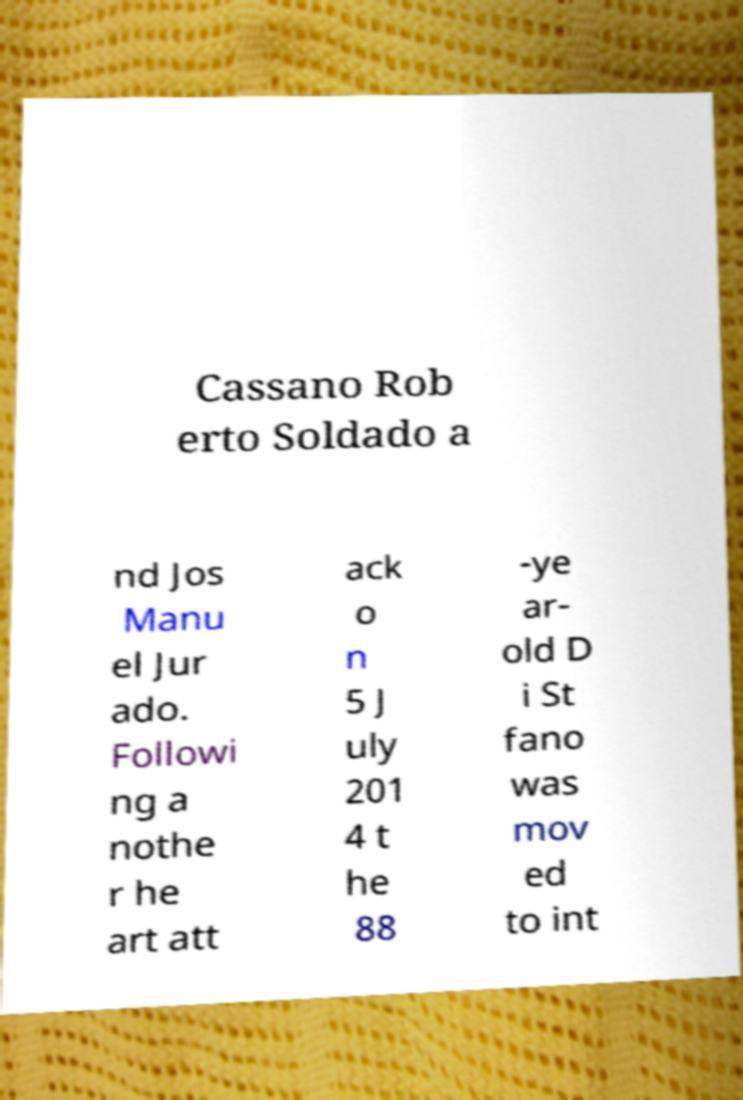Can you accurately transcribe the text from the provided image for me? Cassano Rob erto Soldado a nd Jos Manu el Jur ado. Followi ng a nothe r he art att ack o n 5 J uly 201 4 t he 88 -ye ar- old D i St fano was mov ed to int 